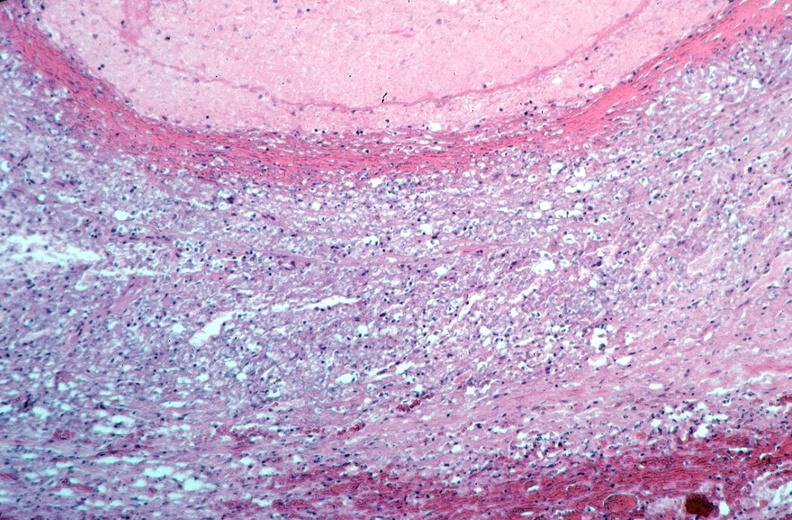s vasculature present?
Answer the question using a single word or phrase. Yes 